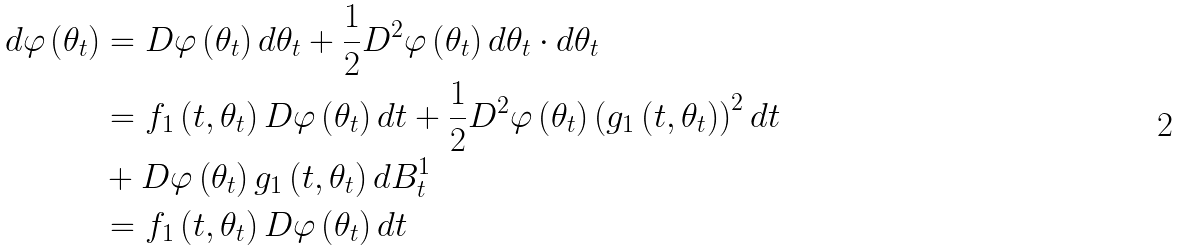<formula> <loc_0><loc_0><loc_500><loc_500>d \varphi \left ( \theta _ { t } \right ) & = D \varphi \left ( \theta _ { t } \right ) d \theta _ { t } + \frac { 1 } { 2 } D ^ { 2 } \varphi \left ( \theta _ { t } \right ) d \theta _ { t } \cdot d \theta _ { t } \\ & = f _ { 1 } \left ( t , \theta _ { t } \right ) D \varphi \left ( \theta _ { t } \right ) d t + \frac { 1 } { 2 } D ^ { 2 } \varphi \left ( \theta _ { t } \right ) \left ( g _ { 1 } \left ( t , \theta _ { t } \right ) \right ) ^ { 2 } d t \\ & + D \varphi \left ( \theta _ { t } \right ) g _ { 1 } \left ( t , \theta _ { t } \right ) d B _ { t } ^ { 1 } \\ & = f _ { 1 } \left ( t , \theta _ { t } \right ) D \varphi \left ( \theta _ { t } \right ) d t</formula> 